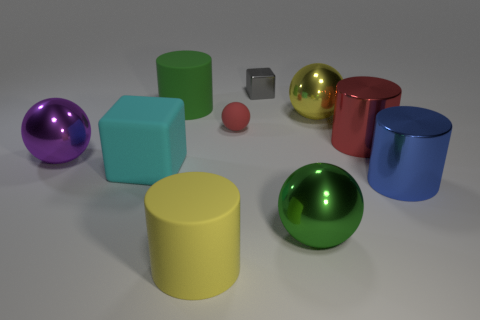Subtract all cylinders. How many objects are left? 6 Add 7 large blocks. How many large blocks exist? 8 Subtract 1 blue cylinders. How many objects are left? 9 Subtract all large blue metal objects. Subtract all big cubes. How many objects are left? 8 Add 2 yellow metal balls. How many yellow metal balls are left? 3 